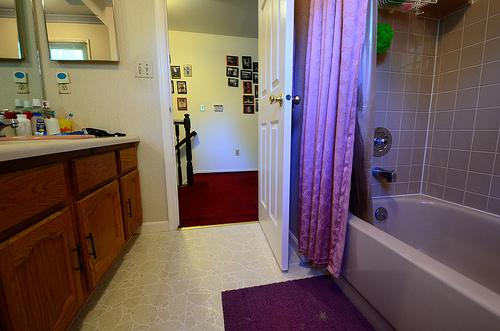Question: what room is this?
Choices:
A. Bedroom.
B. Bathroom.
C. Kitchen.
D. Living Room.
Answer with the letter. Answer: B Question: what color is the shower curtain?
Choices:
A. Brown.
B. Pink.
C. Blue.
D. Green.
Answer with the letter. Answer: B Question: what is the shower curtain made of?
Choices:
A. Plastic.
B. Vinyl.
C. Linen.
D. Silk.
Answer with the letter. Answer: B Question: what is the color of the door?
Choices:
A. Blue.
B. White.
C. Green.
D. Red.
Answer with the letter. Answer: B Question: how many bathtubs are there?
Choices:
A. One.
B. Two.
C. Three.
D. Four.
Answer with the letter. Answer: A Question: why is there a shower curtain?
Choices:
A. So the carpet stays dry.
B. So the floor can be wet.
C. So the floor stays dry.
D. So the bathroom can be furnished.
Answer with the letter. Answer: C 